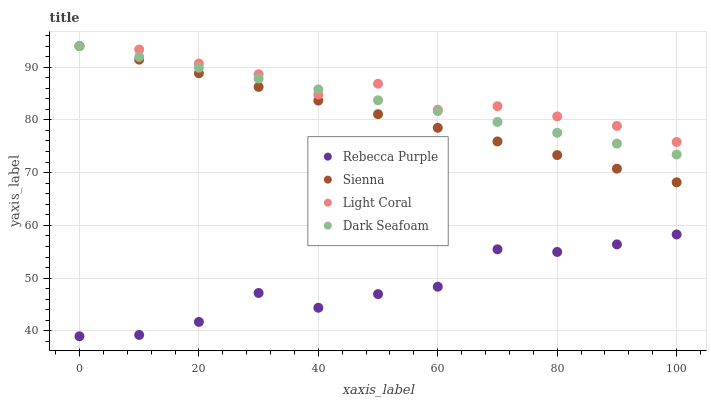Does Rebecca Purple have the minimum area under the curve?
Answer yes or no. Yes. Does Light Coral have the maximum area under the curve?
Answer yes or no. Yes. Does Dark Seafoam have the minimum area under the curve?
Answer yes or no. No. Does Dark Seafoam have the maximum area under the curve?
Answer yes or no. No. Is Sienna the smoothest?
Answer yes or no. Yes. Is Rebecca Purple the roughest?
Answer yes or no. Yes. Is Light Coral the smoothest?
Answer yes or no. No. Is Light Coral the roughest?
Answer yes or no. No. Does Rebecca Purple have the lowest value?
Answer yes or no. Yes. Does Dark Seafoam have the lowest value?
Answer yes or no. No. Does Dark Seafoam have the highest value?
Answer yes or no. Yes. Does Rebecca Purple have the highest value?
Answer yes or no. No. Is Rebecca Purple less than Sienna?
Answer yes or no. Yes. Is Dark Seafoam greater than Rebecca Purple?
Answer yes or no. Yes. Does Dark Seafoam intersect Light Coral?
Answer yes or no. Yes. Is Dark Seafoam less than Light Coral?
Answer yes or no. No. Is Dark Seafoam greater than Light Coral?
Answer yes or no. No. Does Rebecca Purple intersect Sienna?
Answer yes or no. No. 